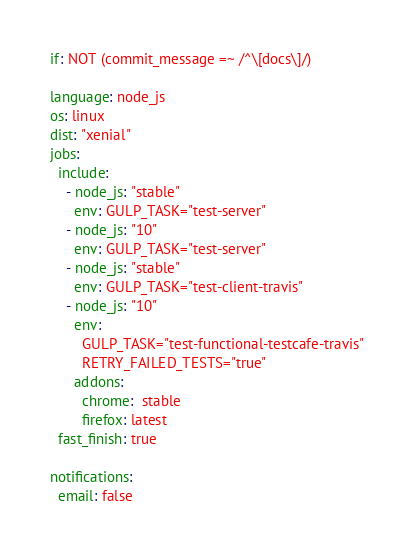Convert code to text. <code><loc_0><loc_0><loc_500><loc_500><_YAML_>if: NOT (commit_message =~ /^\[docs\]/)

language: node_js
os: linux
dist: "xenial"
jobs:
  include:
    - node_js: "stable"
      env: GULP_TASK="test-server"
    - node_js: "10"
      env: GULP_TASK="test-server"
    - node_js: "stable"
      env: GULP_TASK="test-client-travis"
    - node_js: "10"
      env:
        GULP_TASK="test-functional-testcafe-travis"
        RETRY_FAILED_TESTS="true"
      addons:
        chrome:  stable
        firefox: latest
  fast_finish: true

notifications:
  email: false
</code> 